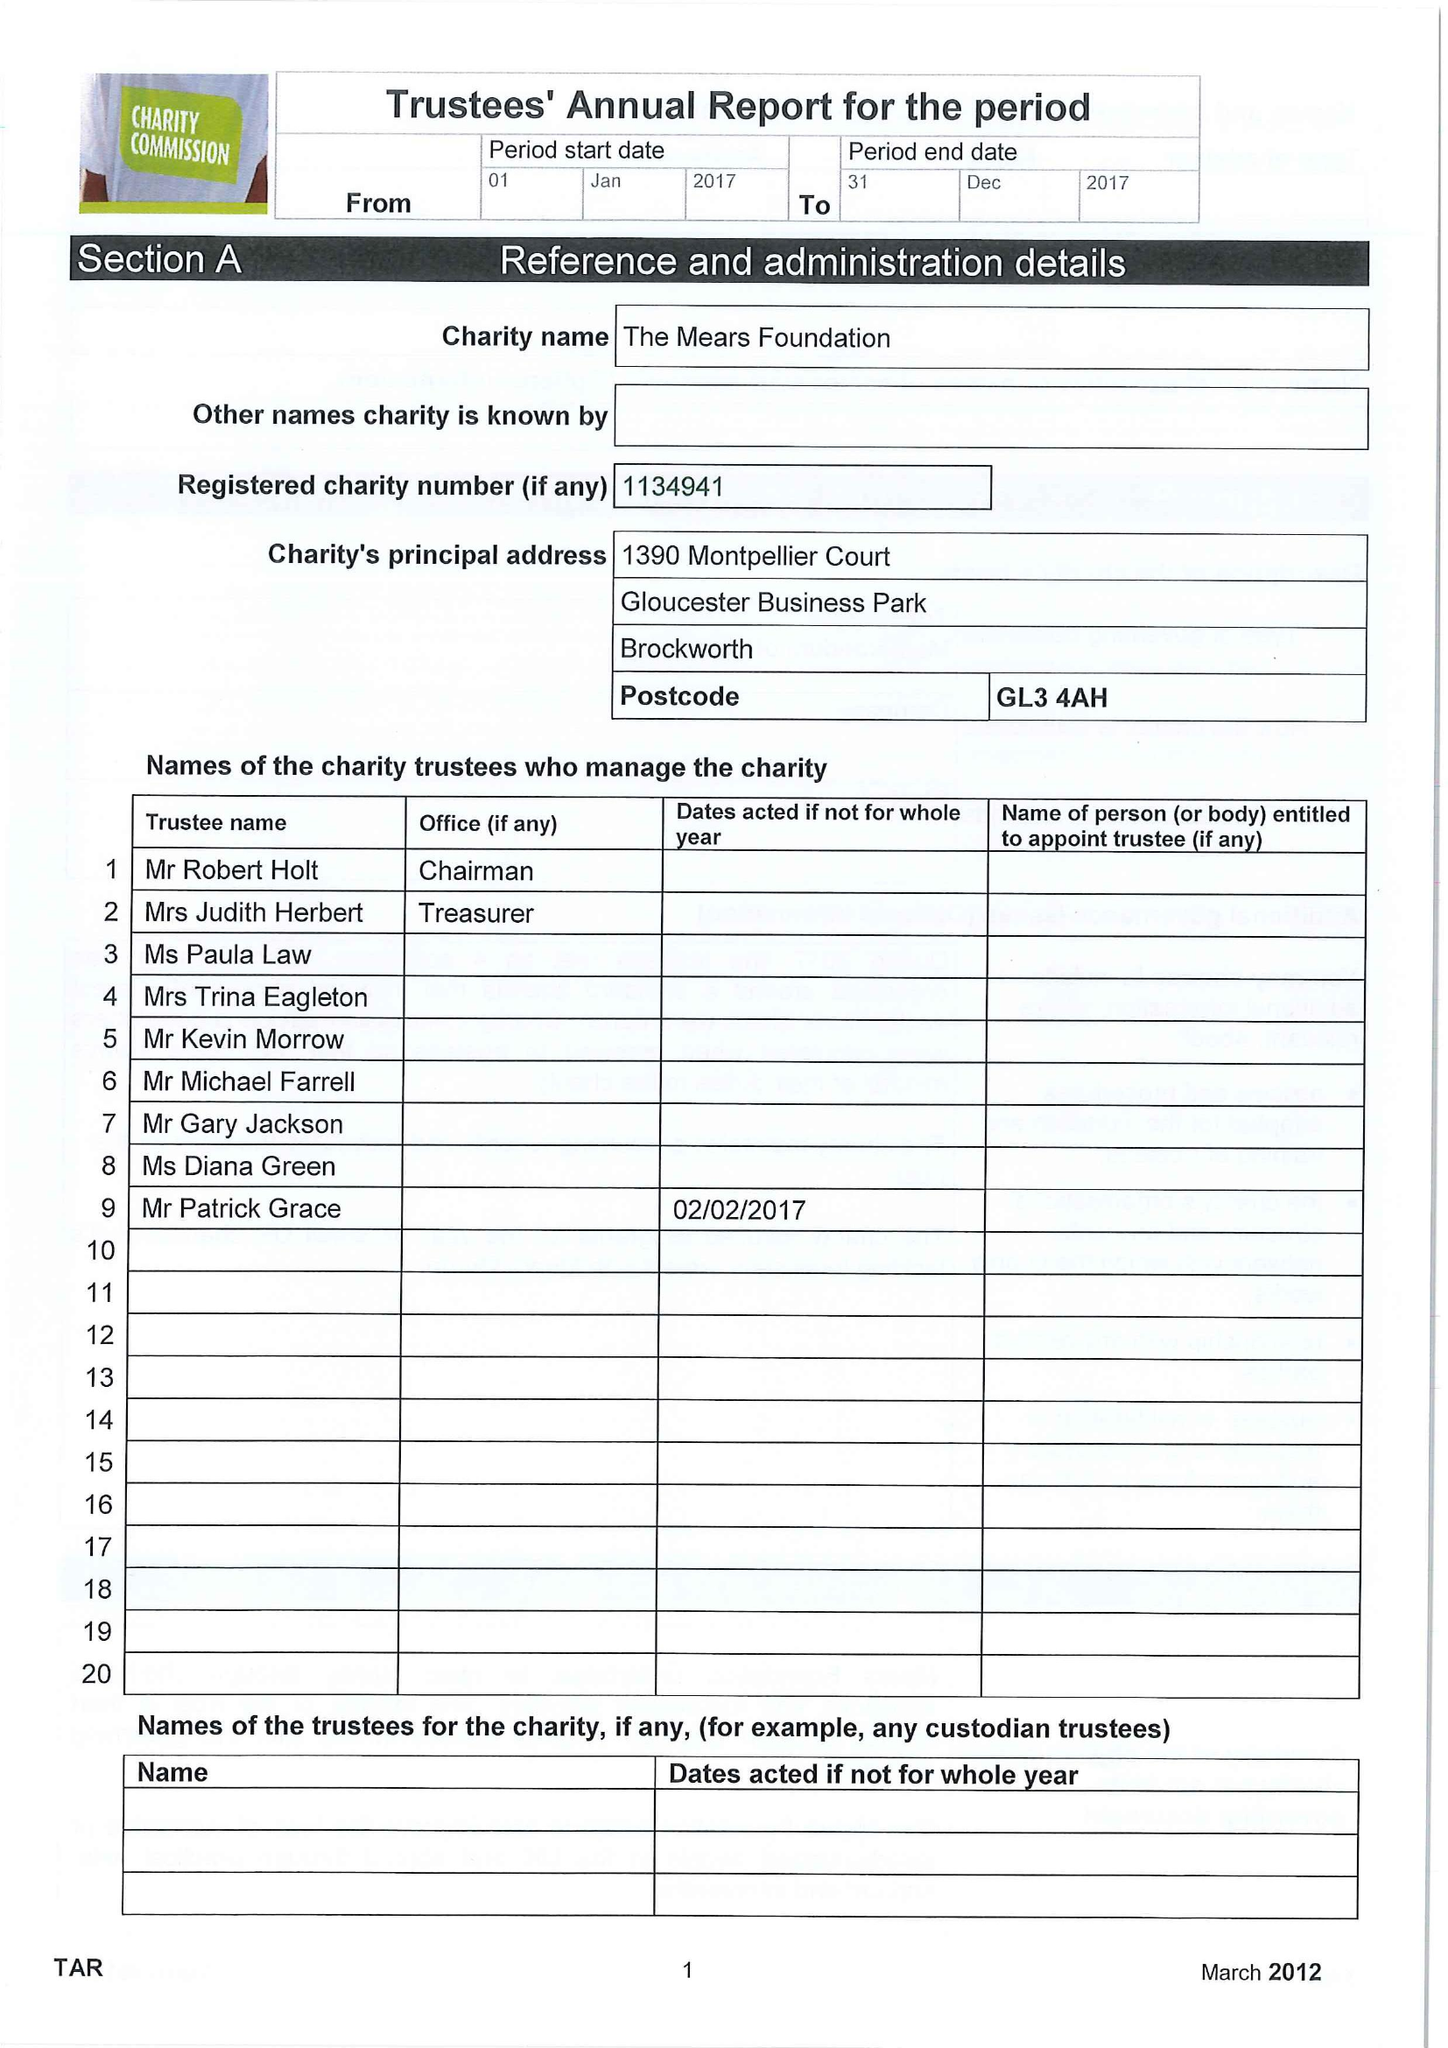What is the value for the charity_number?
Answer the question using a single word or phrase. 1134941 